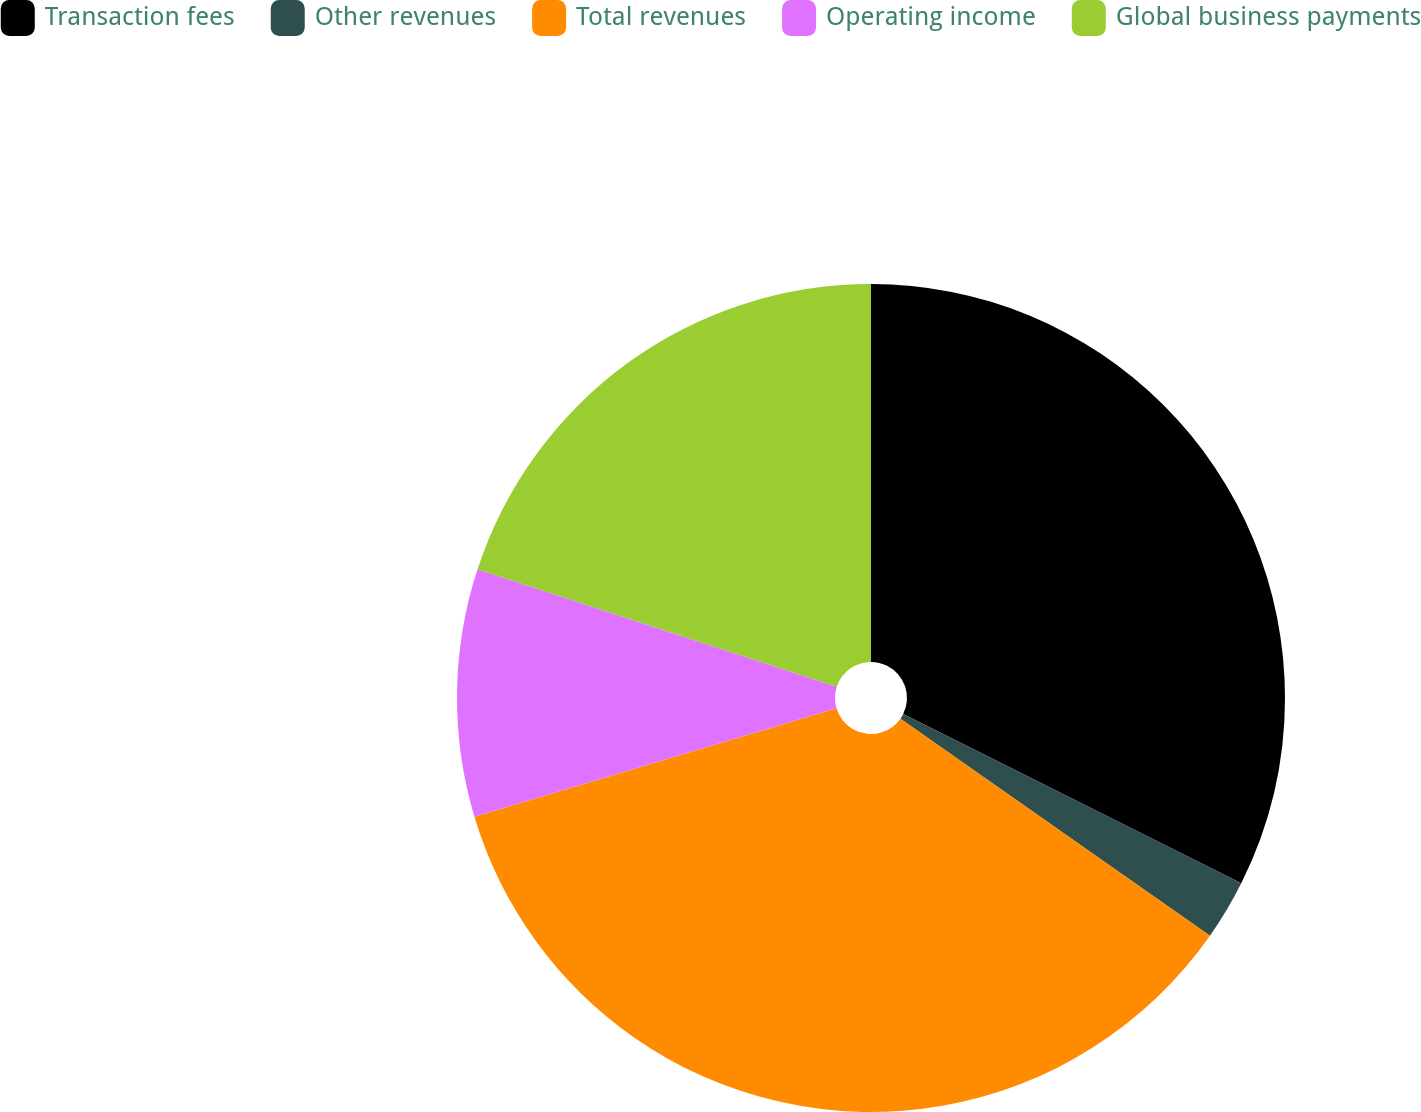Convert chart to OTSL. <chart><loc_0><loc_0><loc_500><loc_500><pie_chart><fcel>Transaction fees<fcel>Other revenues<fcel>Total revenues<fcel>Operating income<fcel>Global business payments<nl><fcel>32.38%<fcel>2.35%<fcel>35.63%<fcel>9.66%<fcel>19.97%<nl></chart> 